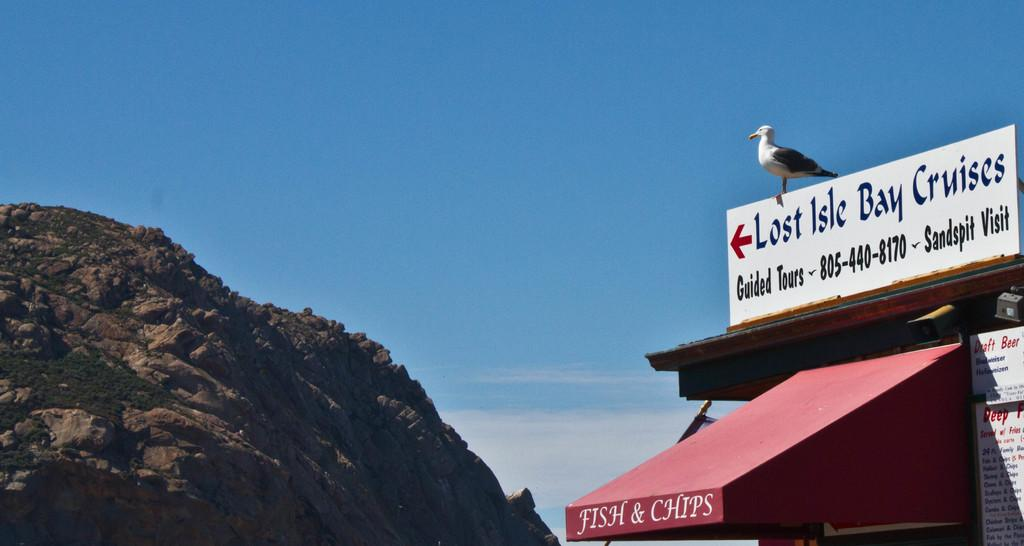<image>
Provide a brief description of the given image. a sign above a building that says 'lost isle bay cruises' 